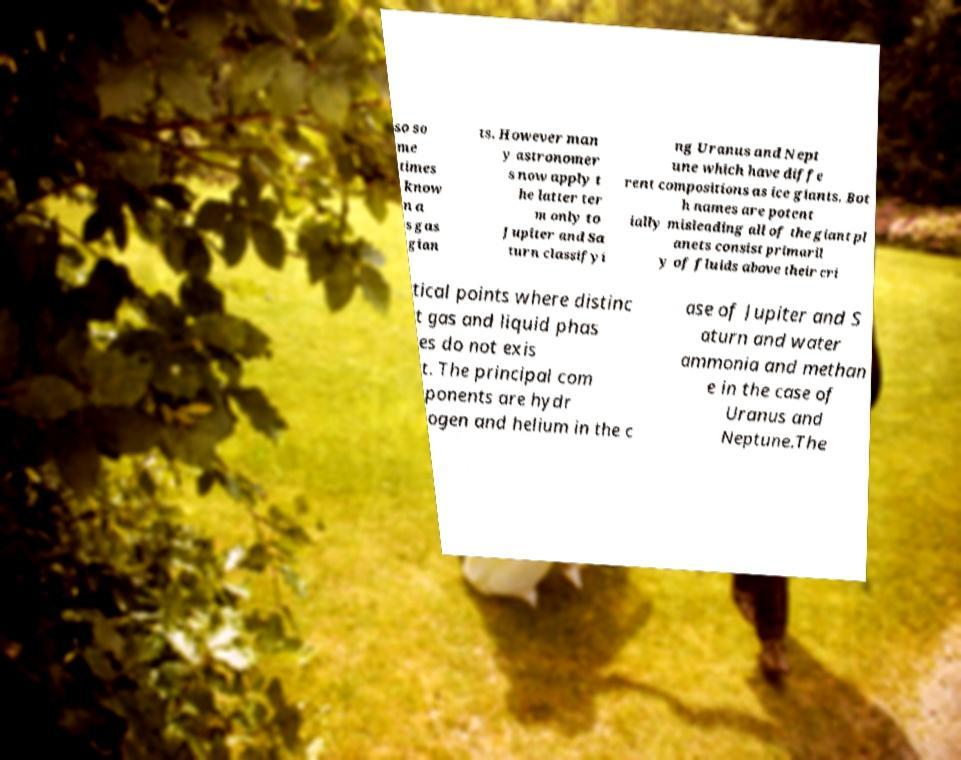For documentation purposes, I need the text within this image transcribed. Could you provide that? so so me times know n a s gas gian ts. However man y astronomer s now apply t he latter ter m only to Jupiter and Sa turn classifyi ng Uranus and Nept une which have diffe rent compositions as ice giants. Bot h names are potent ially misleading all of the giant pl anets consist primaril y of fluids above their cri tical points where distinc t gas and liquid phas es do not exis t. The principal com ponents are hydr ogen and helium in the c ase of Jupiter and S aturn and water ammonia and methan e in the case of Uranus and Neptune.The 